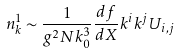Convert formula to latex. <formula><loc_0><loc_0><loc_500><loc_500>n _ { k } ^ { 1 } \sim \frac { 1 } { g ^ { 2 } N k _ { 0 } ^ { 3 } } \frac { d f } { d X } k ^ { i } k ^ { j } U _ { i , j }</formula> 